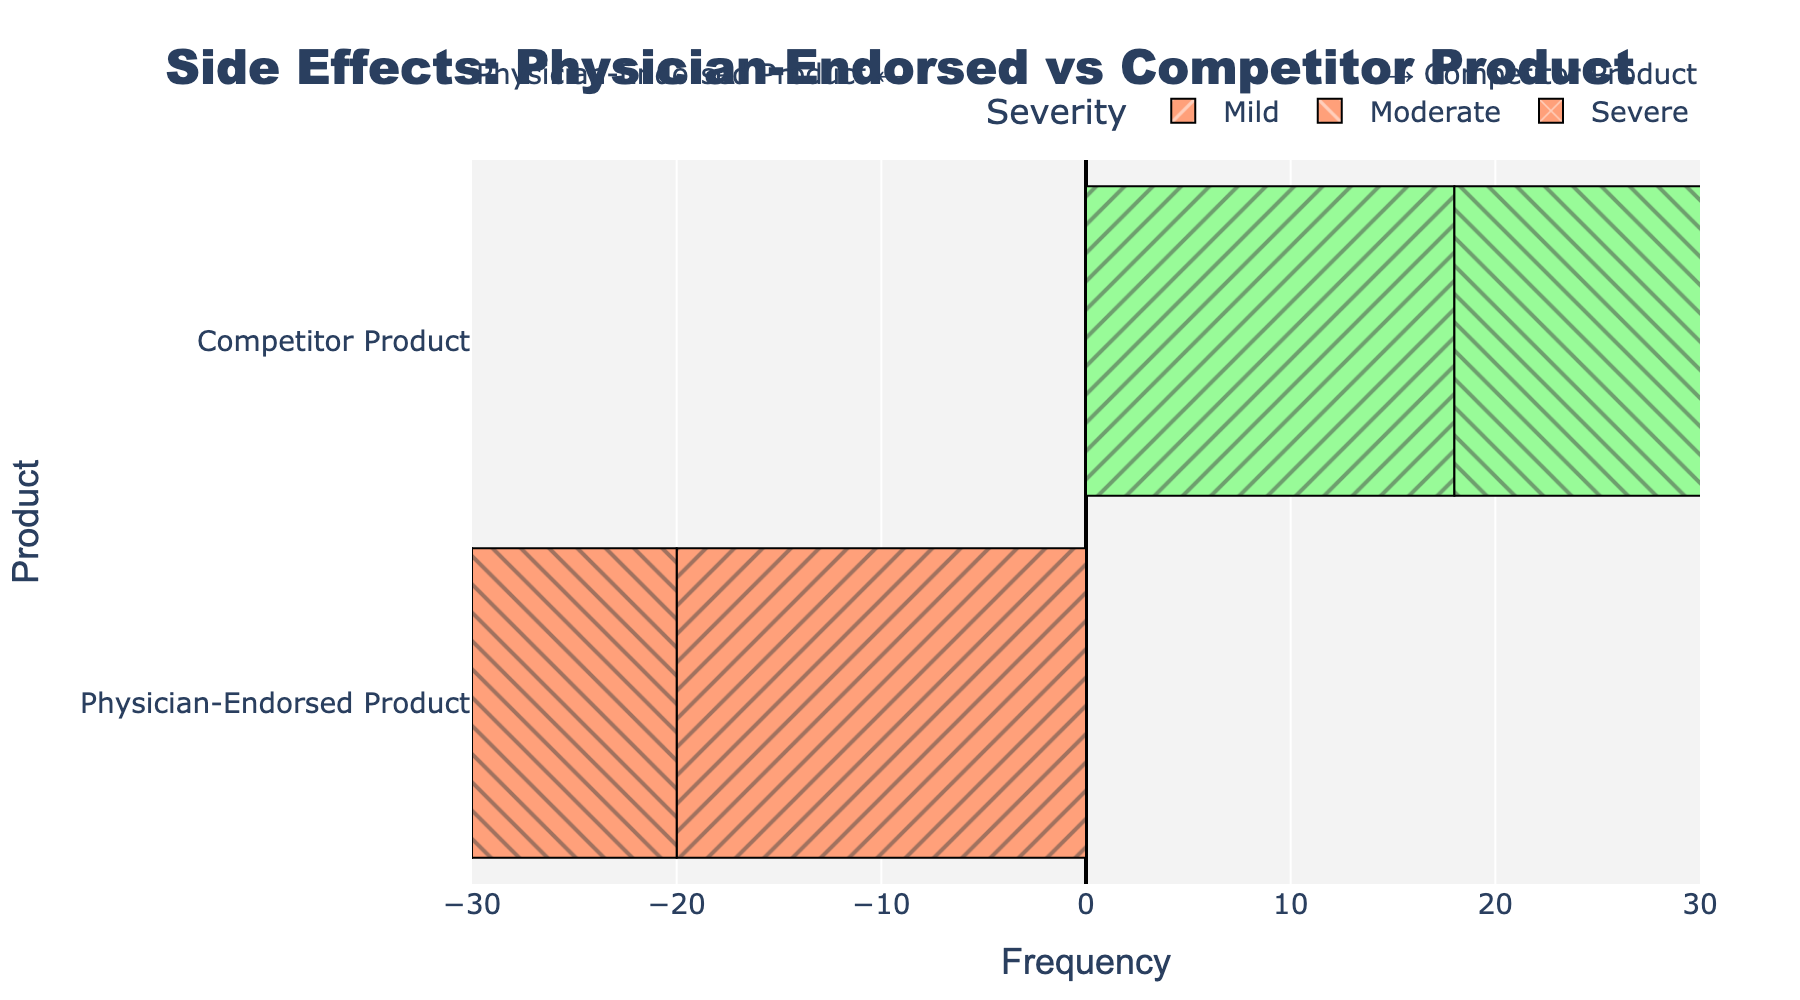Which product has the higher frequency of severe side effects? By comparing the length/height of the bars for severe side effects, the Competitor Product has a higher frequency (positive direction) than the Physician-Endorsed Product (negative direction).
Answer: Competitor Product Between mild and moderate side effects, which severity has a smaller total frequency in the Competitor Product? For mild side effects, the Competitor Product has 18, and for moderate side effects, it has 15. The total frequency for moderate side effects is smaller.
Answer: Moderate What is the combined frequency of severe side effects across both products? The combined frequency is the sum of frequencies for severe side effects for both products: 5 (Physician-Endorsed Product) + 12 (Competitor Product) = 17.
Answer: 17 Is the frequency of mild side effects for the Physician-Endorsed Product greater than that of the Competitor Product? The frequency of mild side effects for the Physician-Endorsed Product is 20, whereas for the Competitor Product, it is 18. 20 is greater than 18.
Answer: Yes Which product experiences more moderate side effects? The bar for moderate side effects is longer for the Competitor Product (15) compared to the Physician-Endorsed Product (10).
Answer: Competitor Product How much higher is the frequency of severe side effects for the Competitor Product compared to the Physician-Endorsed Product? The frequency for the Competitor Product is 12, and for the Physician-Endorsed Product, it is 5. The difference is 12 - 5 = 7.
Answer: 7 What is the total frequency of side effects for the Physician-Endorsed Product? The total frequency is the sum of all side effect frequencies for the Physician-Endorsed Product: 20 (Mild) + 10 (Moderate) + 5 (Severe) = 35.
Answer: 35 Comparing mild and severe side effects for the Physician-Endorsed Product, which severity has the higher frequency? The frequency for mild side effects is 20, and for severe side effects, it is 5. 20 is higher than 5.
Answer: Mild If you were to switch to the Competitor Product, how much more frequent would moderate and severe side effects be combined? For moderate side effects, the increase would be 15 - 10 = 5, and for severe side effects, it would be 12 - 5 = 7. Combined, it would be 5 + 7 = 12.
Answer: 12 